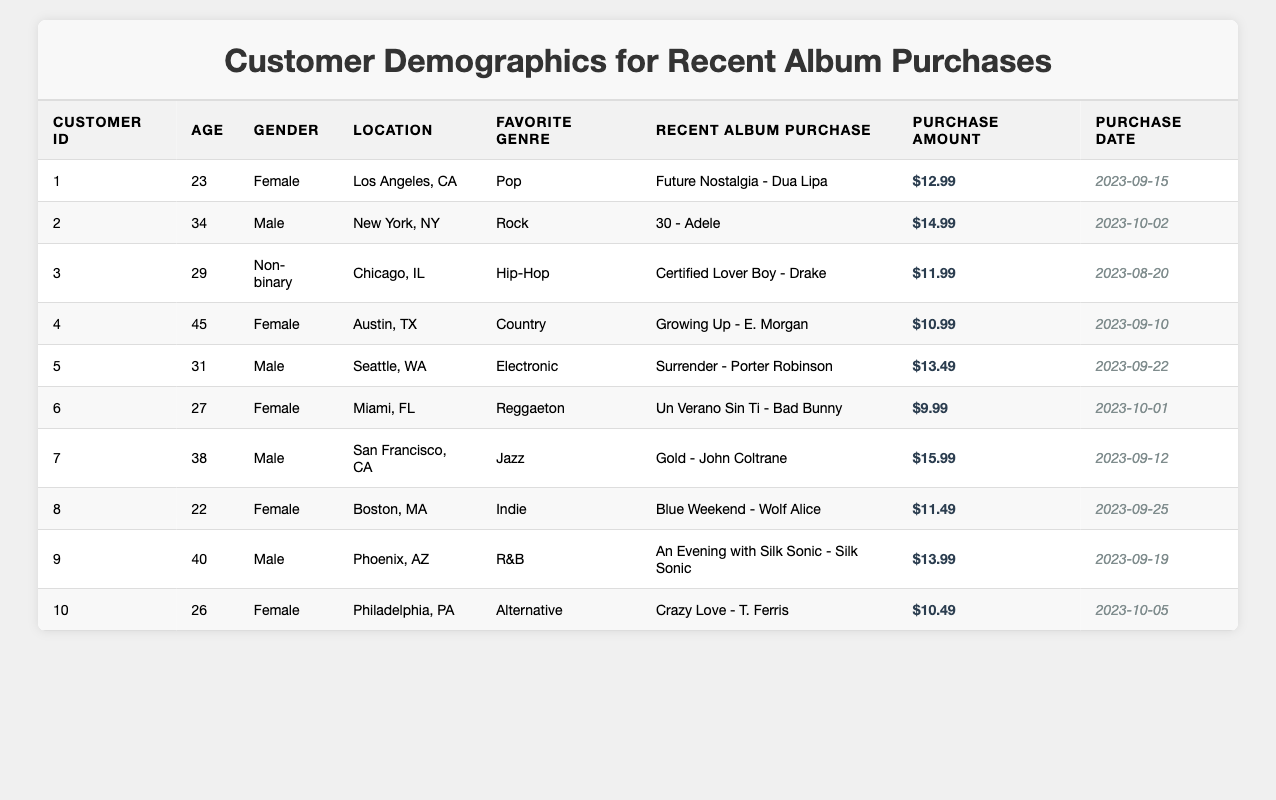What is the most expensive recent album purchase? The album with the highest purchase amount in the table is "Gold - John Coltrane," which costs $15.99.
Answer: $15.99 How many customers are female? By counting the entries where "Gender" is marked as "Female," there are 4 female customers (Customer IDs 1, 4, 6, and 10).
Answer: 4 What is the total amount spent by all customers? To find the total amount spent, we add up all purchase amounts: $12.99 + $14.99 + $11.99 + $10.99 + $13.49 + $9.99 + $15.99 + $11.49 + $13.99 + $10.49 = $134.40.
Answer: $134.40 Which customer has the highest age, and what is that age? The oldest customer is Customer ID 4, who is 45 years old.
Answer: 45 What are the favorite genres of male customers? The favorite genres for male customers (Customer IDs 2, 5, 7, and 9) are Rock, Electronic, Jazz, and R&B respectively.
Answer: Rock, Electronic, Jazz, R&B How many customers have purchased albums in September 2023? By reviewing the purchase dates, 7 customers made purchases in September 2023 (Customer IDs 1, 2, 4, 5, 7, 8, and 9).
Answer: 7 What percentage of customers prefer Pop as their favorite genre? There is 1 customer (Customer ID 1) who prefers Pop, out of 10 total customers, which is 1/10 = 0.1. Therefore, the percentage is 10%.
Answer: 10% What is the average purchase amount across all customers? To find the average purchase amount, we divide the total ($134.40) by the number of customers (10): $134.40 / 10 = $13.44.
Answer: $13.44 Is there any customer who purchased an album on October 5, 2023? Yes, Customer ID 10 made a purchase on October 5, 2023.
Answer: Yes Which two customers purchased albums in the same genre? Customers ID 3 and 6 both purchased albums associated with Hip-Hop and Reggaeton but are from different favorite genres. Thus, no pair fits exactly the same genre as all genres vary.
Answer: None 